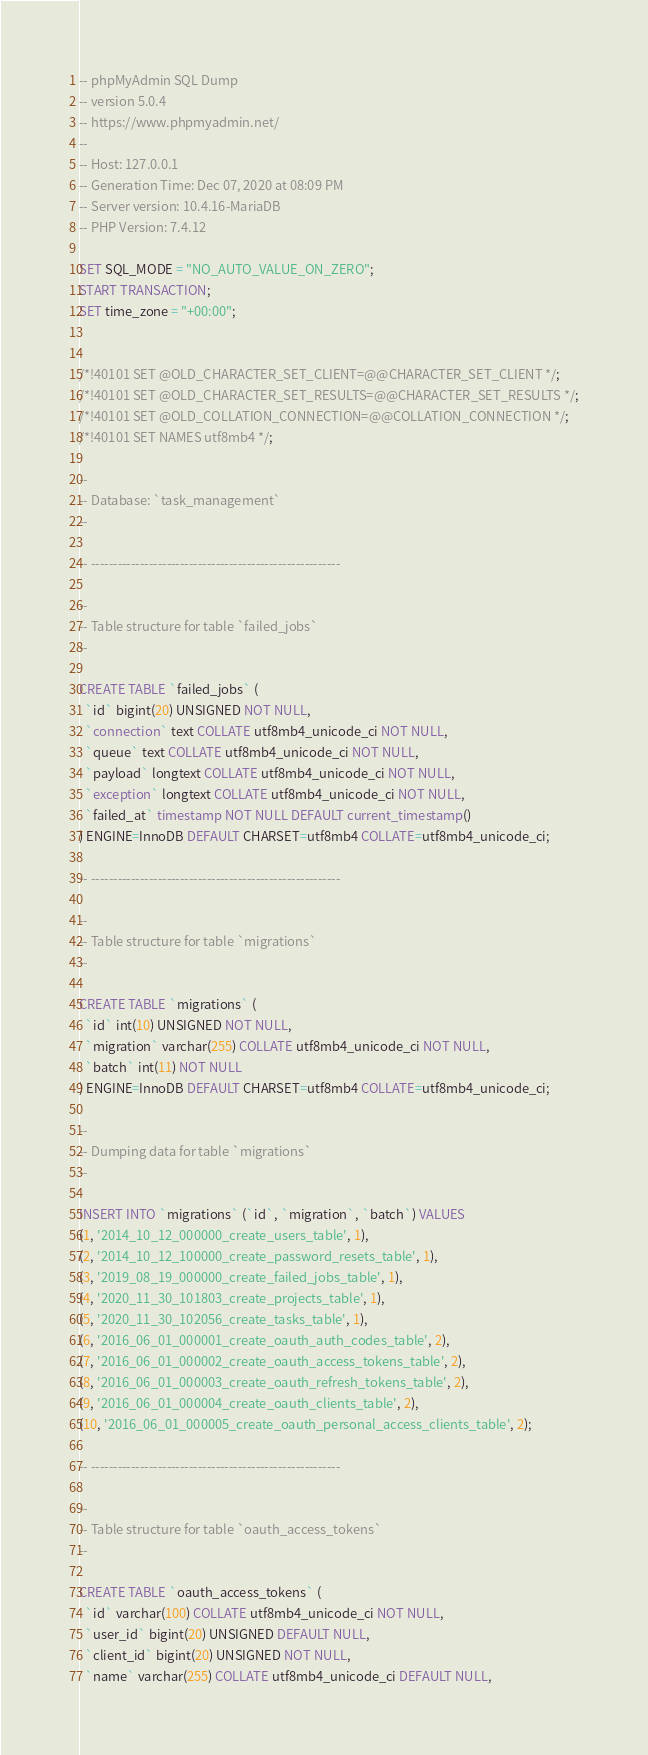Convert code to text. <code><loc_0><loc_0><loc_500><loc_500><_SQL_>-- phpMyAdmin SQL Dump
-- version 5.0.4
-- https://www.phpmyadmin.net/
--
-- Host: 127.0.0.1
-- Generation Time: Dec 07, 2020 at 08:09 PM
-- Server version: 10.4.16-MariaDB
-- PHP Version: 7.4.12

SET SQL_MODE = "NO_AUTO_VALUE_ON_ZERO";
START TRANSACTION;
SET time_zone = "+00:00";


/*!40101 SET @OLD_CHARACTER_SET_CLIENT=@@CHARACTER_SET_CLIENT */;
/*!40101 SET @OLD_CHARACTER_SET_RESULTS=@@CHARACTER_SET_RESULTS */;
/*!40101 SET @OLD_COLLATION_CONNECTION=@@COLLATION_CONNECTION */;
/*!40101 SET NAMES utf8mb4 */;

--
-- Database: `task_management`
--

-- --------------------------------------------------------

--
-- Table structure for table `failed_jobs`
--

CREATE TABLE `failed_jobs` (
  `id` bigint(20) UNSIGNED NOT NULL,
  `connection` text COLLATE utf8mb4_unicode_ci NOT NULL,
  `queue` text COLLATE utf8mb4_unicode_ci NOT NULL,
  `payload` longtext COLLATE utf8mb4_unicode_ci NOT NULL,
  `exception` longtext COLLATE utf8mb4_unicode_ci NOT NULL,
  `failed_at` timestamp NOT NULL DEFAULT current_timestamp()
) ENGINE=InnoDB DEFAULT CHARSET=utf8mb4 COLLATE=utf8mb4_unicode_ci;

-- --------------------------------------------------------

--
-- Table structure for table `migrations`
--

CREATE TABLE `migrations` (
  `id` int(10) UNSIGNED NOT NULL,
  `migration` varchar(255) COLLATE utf8mb4_unicode_ci NOT NULL,
  `batch` int(11) NOT NULL
) ENGINE=InnoDB DEFAULT CHARSET=utf8mb4 COLLATE=utf8mb4_unicode_ci;

--
-- Dumping data for table `migrations`
--

INSERT INTO `migrations` (`id`, `migration`, `batch`) VALUES
(1, '2014_10_12_000000_create_users_table', 1),
(2, '2014_10_12_100000_create_password_resets_table', 1),
(3, '2019_08_19_000000_create_failed_jobs_table', 1),
(4, '2020_11_30_101803_create_projects_table', 1),
(5, '2020_11_30_102056_create_tasks_table', 1),
(6, '2016_06_01_000001_create_oauth_auth_codes_table', 2),
(7, '2016_06_01_000002_create_oauth_access_tokens_table', 2),
(8, '2016_06_01_000003_create_oauth_refresh_tokens_table', 2),
(9, '2016_06_01_000004_create_oauth_clients_table', 2),
(10, '2016_06_01_000005_create_oauth_personal_access_clients_table', 2);

-- --------------------------------------------------------

--
-- Table structure for table `oauth_access_tokens`
--

CREATE TABLE `oauth_access_tokens` (
  `id` varchar(100) COLLATE utf8mb4_unicode_ci NOT NULL,
  `user_id` bigint(20) UNSIGNED DEFAULT NULL,
  `client_id` bigint(20) UNSIGNED NOT NULL,
  `name` varchar(255) COLLATE utf8mb4_unicode_ci DEFAULT NULL,</code> 